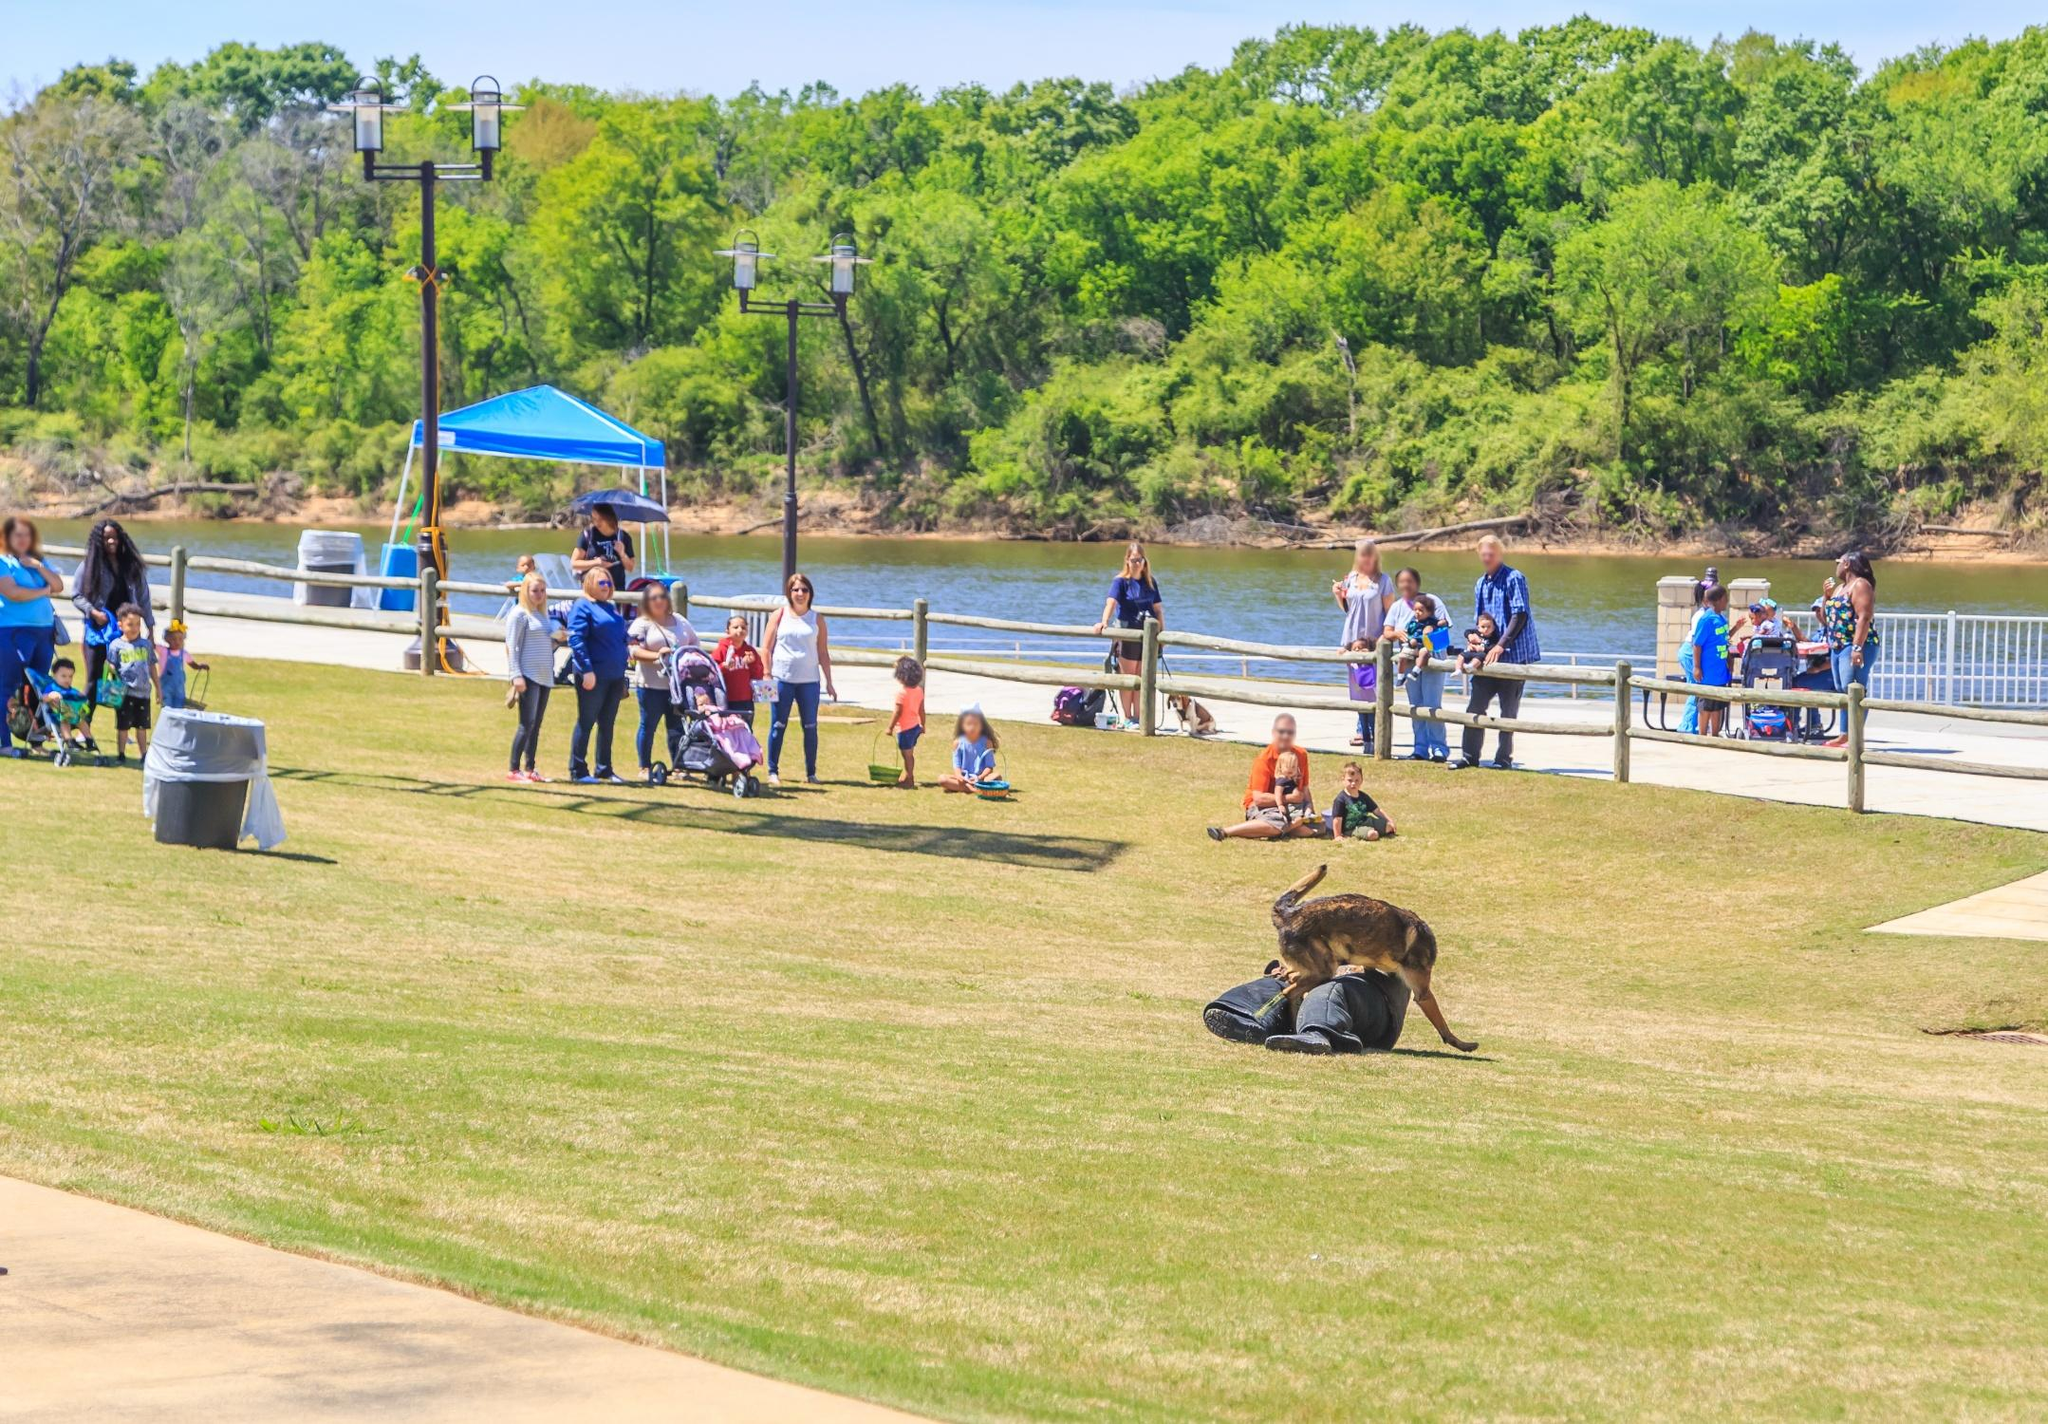What could the dog be thinking while it sniffs the backpack? The dog, while sniffing the backpack, might be thinking, "What an interesting smell! I wonder if there are any treats inside. Maybe this belongs to a kid who has been playing a lot, I can smell grass and sugar. Or perhaps this person has another pet at home, I can detect hints of another animal’s scent." 